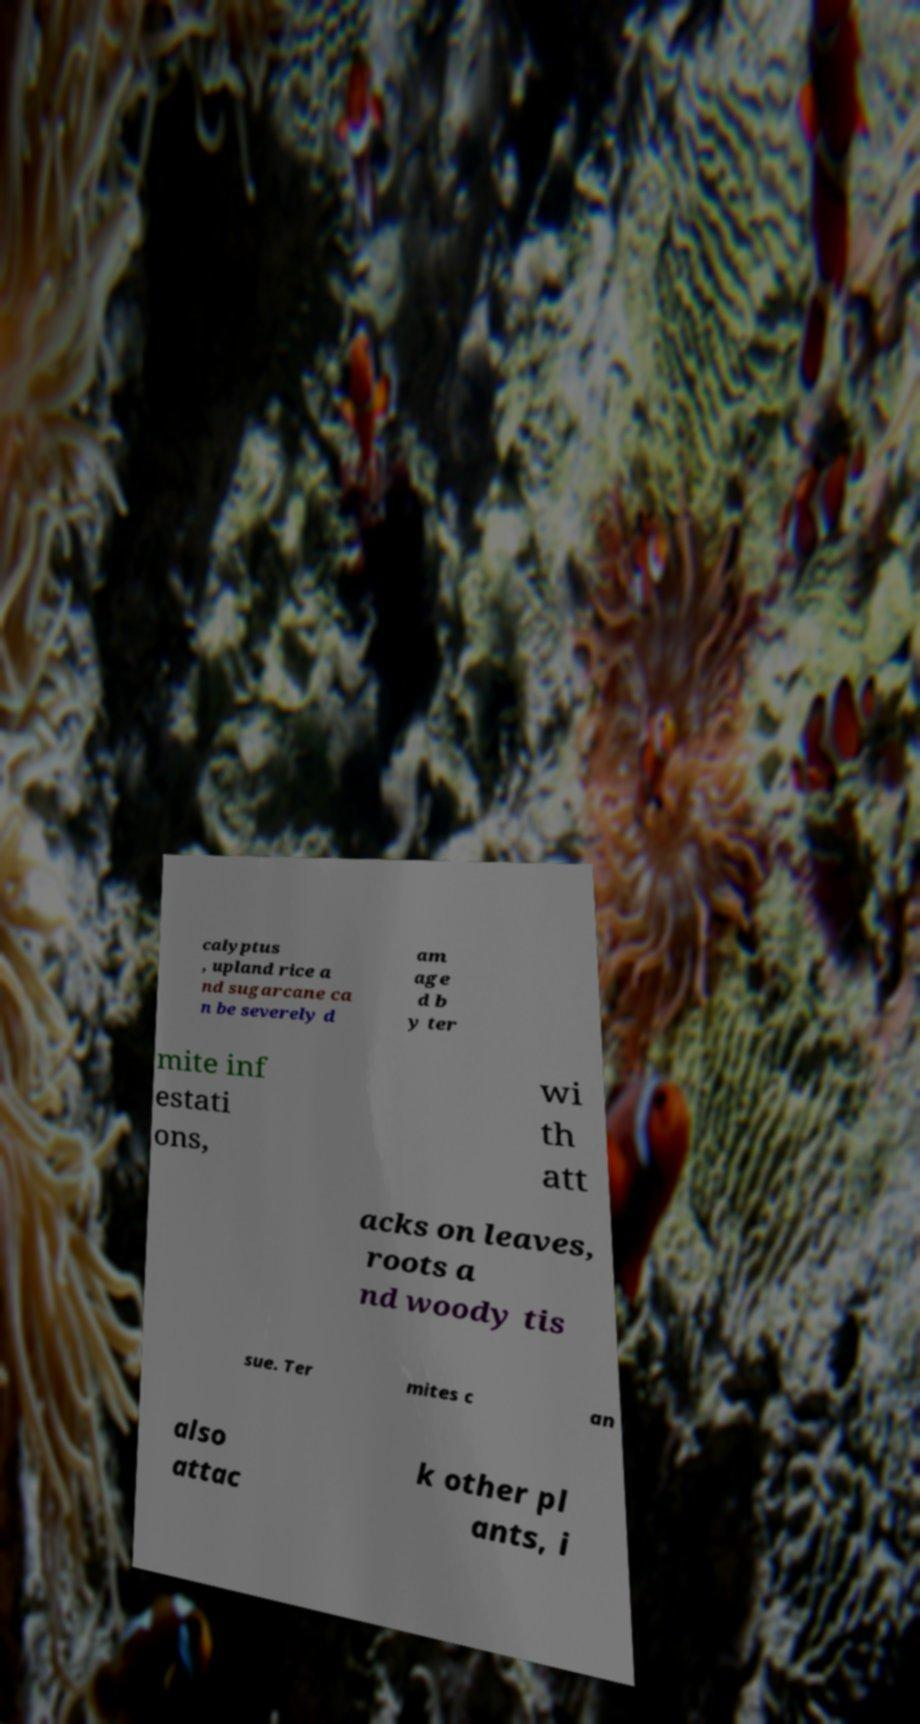Please identify and transcribe the text found in this image. calyptus , upland rice a nd sugarcane ca n be severely d am age d b y ter mite inf estati ons, wi th att acks on leaves, roots a nd woody tis sue. Ter mites c an also attac k other pl ants, i 